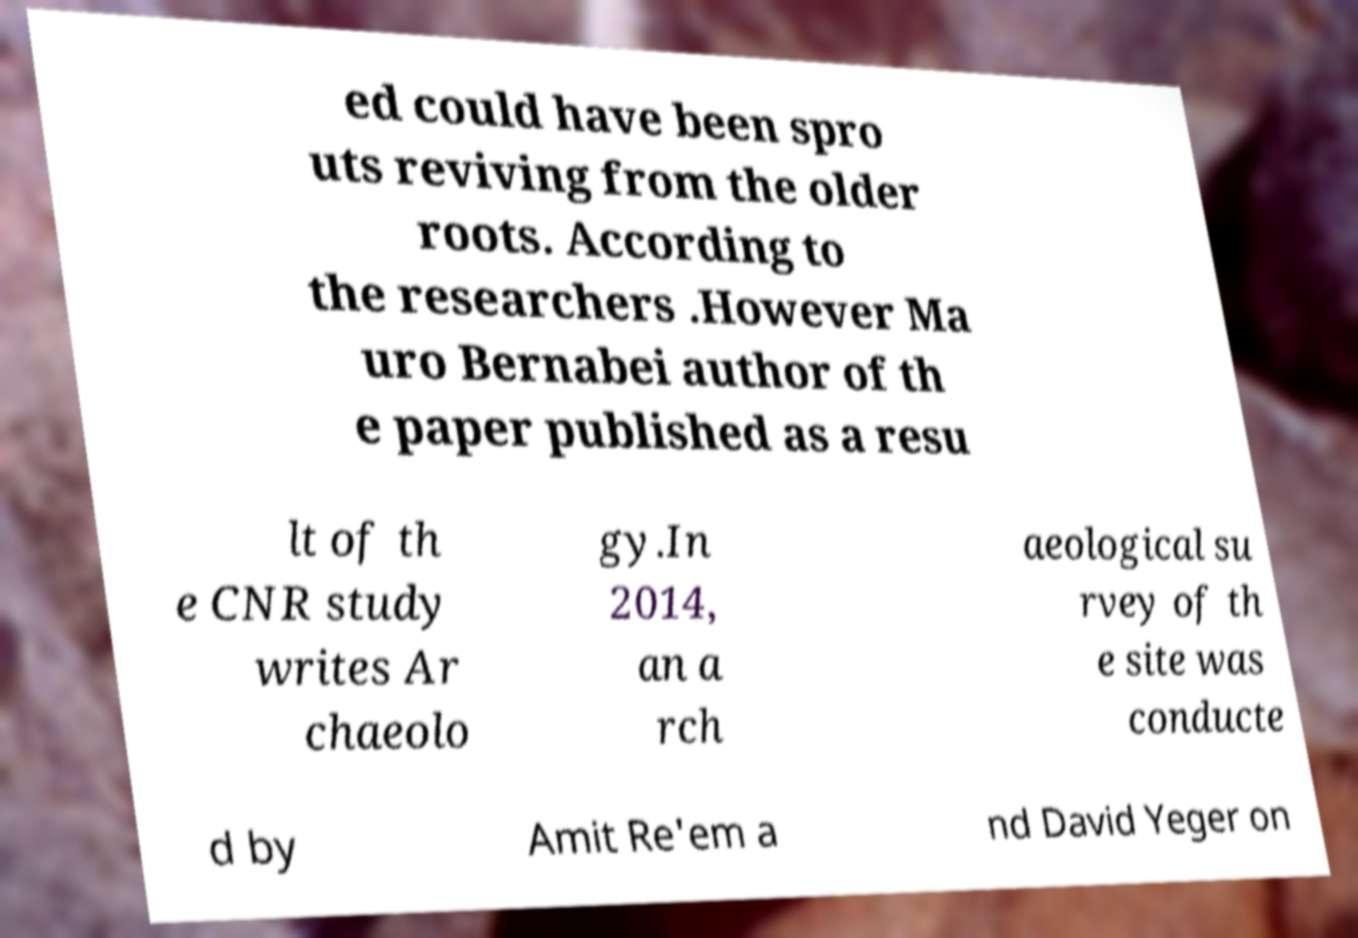For documentation purposes, I need the text within this image transcribed. Could you provide that? ed could have been spro uts reviving from the older roots. According to the researchers .However Ma uro Bernabei author of th e paper published as a resu lt of th e CNR study writes Ar chaeolo gy.In 2014, an a rch aeological su rvey of th e site was conducte d by Amit Re'em a nd David Yeger on 